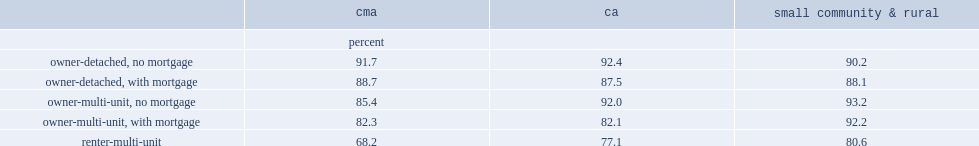Could you help me parse every detail presented in this table? {'header': ['', 'cma', 'ca', 'small community & rural'], 'rows': [['', 'percent', '', ''], ['owner-detached, no mortgage', '91.7', '92.4', '90.2'], ['owner-detached, with mortgage', '88.7', '87.5', '88.1'], ['owner-multi-unit, no mortgage', '85.4', '92.0', '93.2'], ['owner-multi-unit, with mortgage', '82.3', '82.1', '92.2'], ['renter-multi-unit', '68.2', '77.1', '80.6']]} How many percent of housing satisfaction rate are lower among households that have a mortgage on their owned-detached house than among those who are mortgage free in cmas? 3. How many percent of housing satisfaction is lower among owners of multi-unit dwellings who have a mortgage than among those who do not in cas? 10.3. 